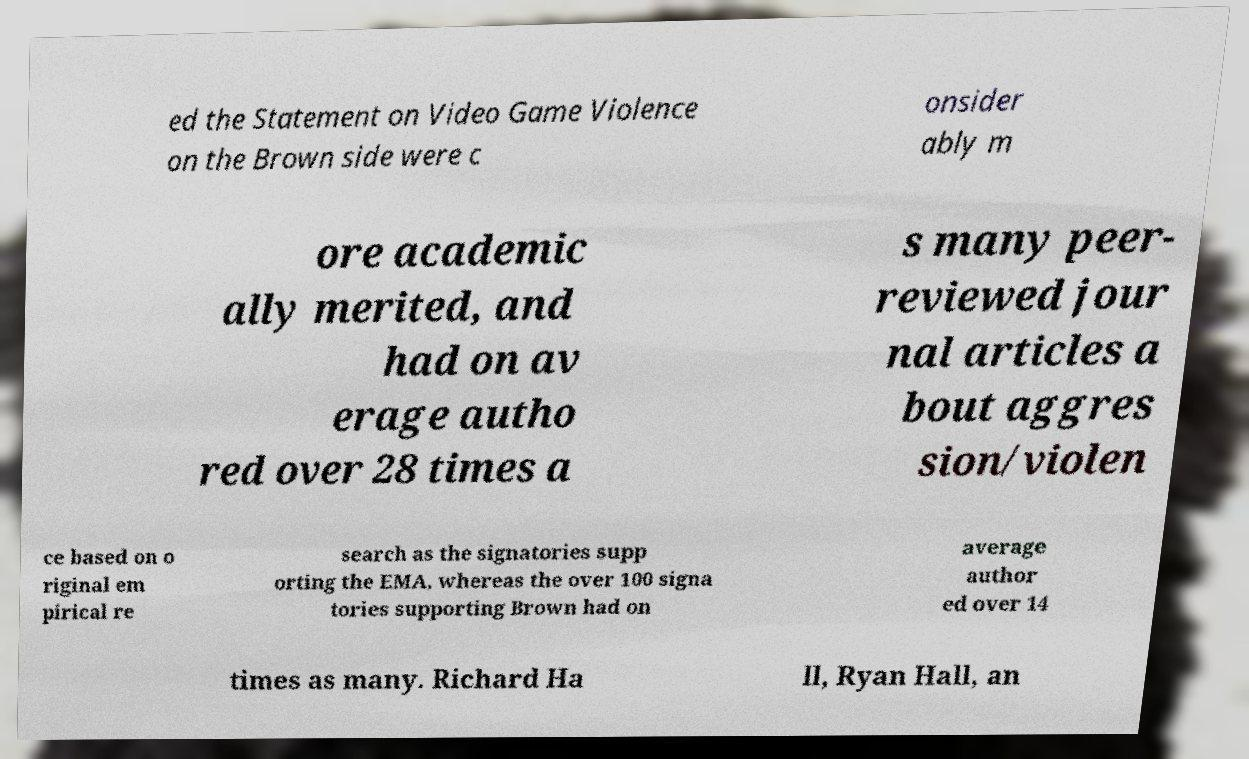What messages or text are displayed in this image? I need them in a readable, typed format. ed the Statement on Video Game Violence on the Brown side were c onsider ably m ore academic ally merited, and had on av erage autho red over 28 times a s many peer- reviewed jour nal articles a bout aggres sion/violen ce based on o riginal em pirical re search as the signatories supp orting the EMA, whereas the over 100 signa tories supporting Brown had on average author ed over 14 times as many. Richard Ha ll, Ryan Hall, an 